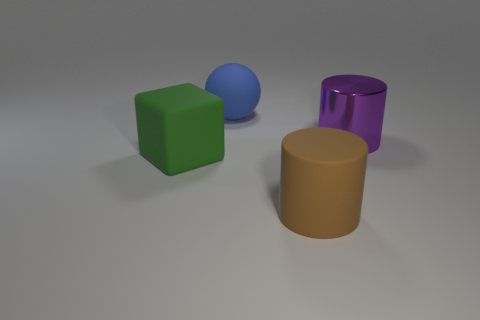What number of green objects are large cubes or objects?
Offer a very short reply. 1. How big is the matte object that is both in front of the metal cylinder and on the left side of the big brown cylinder?
Your answer should be compact. Large. Are there more big cylinders behind the green thing than small blue metallic spheres?
Give a very brief answer. Yes. What number of spheres are either purple shiny objects or green things?
Your response must be concise. 0. There is a rubber object that is both in front of the big blue rubber sphere and on the left side of the brown thing; what is its shape?
Your response must be concise. Cube. Are there the same number of green cubes in front of the brown cylinder and metallic cylinders that are behind the shiny cylinder?
Keep it short and to the point. Yes. What number of things are purple metallic cylinders or large blue matte things?
Make the answer very short. 2. There is a rubber ball that is the same size as the cube; what color is it?
Provide a succinct answer. Blue. What number of objects are either big cylinders that are to the left of the purple metallic object or rubber objects behind the big green rubber object?
Offer a very short reply. 2. Is the number of cylinders behind the blue matte ball the same as the number of large purple spheres?
Your answer should be compact. Yes. 